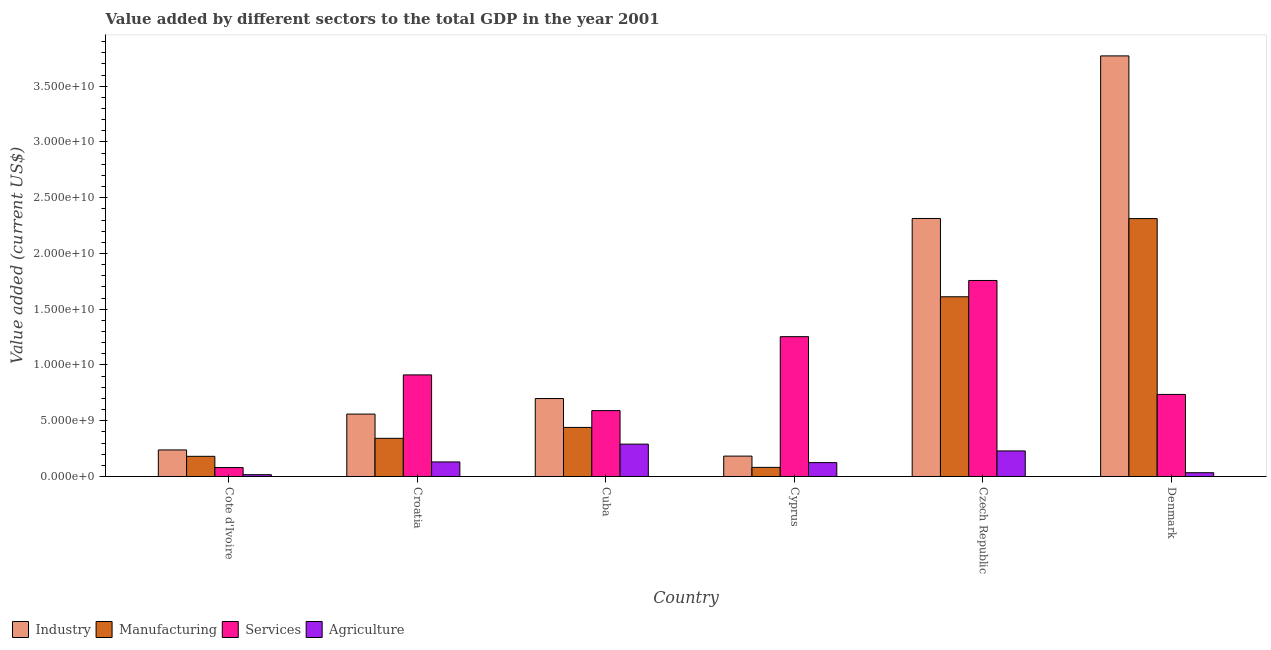Are the number of bars per tick equal to the number of legend labels?
Ensure brevity in your answer.  Yes. How many bars are there on the 6th tick from the left?
Give a very brief answer. 4. How many bars are there on the 3rd tick from the right?
Provide a succinct answer. 4. What is the label of the 5th group of bars from the left?
Your answer should be compact. Czech Republic. What is the value added by manufacturing sector in Cyprus?
Give a very brief answer. 8.16e+08. Across all countries, what is the maximum value added by manufacturing sector?
Give a very brief answer. 2.31e+1. Across all countries, what is the minimum value added by services sector?
Offer a terse response. 8.02e+08. In which country was the value added by industrial sector minimum?
Ensure brevity in your answer.  Cyprus. What is the total value added by services sector in the graph?
Your response must be concise. 5.33e+1. What is the difference between the value added by agricultural sector in Cote d'Ivoire and that in Cyprus?
Provide a succinct answer. -1.08e+09. What is the difference between the value added by manufacturing sector in Croatia and the value added by industrial sector in Cyprus?
Ensure brevity in your answer.  1.59e+09. What is the average value added by industrial sector per country?
Provide a short and direct response. 1.29e+1. What is the difference between the value added by services sector and value added by industrial sector in Cuba?
Offer a very short reply. -1.08e+09. In how many countries, is the value added by industrial sector greater than 5000000000 US$?
Your answer should be very brief. 4. What is the ratio of the value added by manufacturing sector in Cuba to that in Cyprus?
Give a very brief answer. 5.4. Is the difference between the value added by agricultural sector in Czech Republic and Denmark greater than the difference between the value added by industrial sector in Czech Republic and Denmark?
Offer a very short reply. Yes. What is the difference between the highest and the second highest value added by manufacturing sector?
Provide a short and direct response. 7.01e+09. What is the difference between the highest and the lowest value added by manufacturing sector?
Give a very brief answer. 2.23e+1. What does the 1st bar from the left in Croatia represents?
Ensure brevity in your answer.  Industry. What does the 2nd bar from the right in Croatia represents?
Offer a terse response. Services. How many bars are there?
Your response must be concise. 24. Are all the bars in the graph horizontal?
Your answer should be compact. No. What is the difference between two consecutive major ticks on the Y-axis?
Offer a very short reply. 5.00e+09. Does the graph contain grids?
Ensure brevity in your answer.  No. Where does the legend appear in the graph?
Your answer should be very brief. Bottom left. How many legend labels are there?
Provide a short and direct response. 4. What is the title of the graph?
Offer a terse response. Value added by different sectors to the total GDP in the year 2001. What is the label or title of the X-axis?
Your answer should be compact. Country. What is the label or title of the Y-axis?
Offer a terse response. Value added (current US$). What is the Value added (current US$) in Industry in Cote d'Ivoire?
Your answer should be compact. 2.38e+09. What is the Value added (current US$) of Manufacturing in Cote d'Ivoire?
Your answer should be compact. 1.81e+09. What is the Value added (current US$) of Services in Cote d'Ivoire?
Provide a succinct answer. 8.02e+08. What is the Value added (current US$) in Agriculture in Cote d'Ivoire?
Offer a very short reply. 1.62e+08. What is the Value added (current US$) of Industry in Croatia?
Your answer should be very brief. 5.60e+09. What is the Value added (current US$) of Manufacturing in Croatia?
Your answer should be very brief. 3.42e+09. What is the Value added (current US$) of Services in Croatia?
Your response must be concise. 9.11e+09. What is the Value added (current US$) of Agriculture in Croatia?
Your answer should be compact. 1.30e+09. What is the Value added (current US$) of Industry in Cuba?
Keep it short and to the point. 6.99e+09. What is the Value added (current US$) in Manufacturing in Cuba?
Keep it short and to the point. 4.40e+09. What is the Value added (current US$) of Services in Cuba?
Provide a succinct answer. 5.91e+09. What is the Value added (current US$) of Agriculture in Cuba?
Provide a succinct answer. 2.90e+09. What is the Value added (current US$) of Industry in Cyprus?
Your response must be concise. 1.83e+09. What is the Value added (current US$) of Manufacturing in Cyprus?
Provide a short and direct response. 8.16e+08. What is the Value added (current US$) of Services in Cyprus?
Your answer should be very brief. 1.25e+1. What is the Value added (current US$) in Agriculture in Cyprus?
Offer a very short reply. 1.24e+09. What is the Value added (current US$) of Industry in Czech Republic?
Your answer should be very brief. 2.31e+1. What is the Value added (current US$) of Manufacturing in Czech Republic?
Offer a terse response. 1.61e+1. What is the Value added (current US$) of Services in Czech Republic?
Your response must be concise. 1.76e+1. What is the Value added (current US$) of Agriculture in Czech Republic?
Provide a short and direct response. 2.29e+09. What is the Value added (current US$) in Industry in Denmark?
Ensure brevity in your answer.  3.77e+1. What is the Value added (current US$) of Manufacturing in Denmark?
Give a very brief answer. 2.31e+1. What is the Value added (current US$) of Services in Denmark?
Ensure brevity in your answer.  7.36e+09. What is the Value added (current US$) of Agriculture in Denmark?
Give a very brief answer. 3.39e+08. Across all countries, what is the maximum Value added (current US$) in Industry?
Ensure brevity in your answer.  3.77e+1. Across all countries, what is the maximum Value added (current US$) of Manufacturing?
Offer a very short reply. 2.31e+1. Across all countries, what is the maximum Value added (current US$) of Services?
Your response must be concise. 1.76e+1. Across all countries, what is the maximum Value added (current US$) in Agriculture?
Offer a very short reply. 2.90e+09. Across all countries, what is the minimum Value added (current US$) of Industry?
Offer a very short reply. 1.83e+09. Across all countries, what is the minimum Value added (current US$) in Manufacturing?
Offer a terse response. 8.16e+08. Across all countries, what is the minimum Value added (current US$) of Services?
Keep it short and to the point. 8.02e+08. Across all countries, what is the minimum Value added (current US$) of Agriculture?
Your response must be concise. 1.62e+08. What is the total Value added (current US$) of Industry in the graph?
Give a very brief answer. 7.77e+1. What is the total Value added (current US$) of Manufacturing in the graph?
Your response must be concise. 4.97e+1. What is the total Value added (current US$) in Services in the graph?
Give a very brief answer. 5.33e+1. What is the total Value added (current US$) of Agriculture in the graph?
Ensure brevity in your answer.  8.24e+09. What is the difference between the Value added (current US$) of Industry in Cote d'Ivoire and that in Croatia?
Keep it short and to the point. -3.21e+09. What is the difference between the Value added (current US$) in Manufacturing in Cote d'Ivoire and that in Croatia?
Give a very brief answer. -1.61e+09. What is the difference between the Value added (current US$) of Services in Cote d'Ivoire and that in Croatia?
Offer a terse response. -8.31e+09. What is the difference between the Value added (current US$) of Agriculture in Cote d'Ivoire and that in Croatia?
Your answer should be compact. -1.14e+09. What is the difference between the Value added (current US$) of Industry in Cote d'Ivoire and that in Cuba?
Offer a terse response. -4.61e+09. What is the difference between the Value added (current US$) in Manufacturing in Cote d'Ivoire and that in Cuba?
Give a very brief answer. -2.59e+09. What is the difference between the Value added (current US$) in Services in Cote d'Ivoire and that in Cuba?
Your response must be concise. -5.11e+09. What is the difference between the Value added (current US$) in Agriculture in Cote d'Ivoire and that in Cuba?
Your response must be concise. -2.74e+09. What is the difference between the Value added (current US$) of Industry in Cote d'Ivoire and that in Cyprus?
Your answer should be very brief. 5.53e+08. What is the difference between the Value added (current US$) in Manufacturing in Cote d'Ivoire and that in Cyprus?
Your answer should be compact. 9.93e+08. What is the difference between the Value added (current US$) in Services in Cote d'Ivoire and that in Cyprus?
Offer a very short reply. -1.17e+1. What is the difference between the Value added (current US$) in Agriculture in Cote d'Ivoire and that in Cyprus?
Offer a very short reply. -1.08e+09. What is the difference between the Value added (current US$) of Industry in Cote d'Ivoire and that in Czech Republic?
Make the answer very short. -2.08e+1. What is the difference between the Value added (current US$) in Manufacturing in Cote d'Ivoire and that in Czech Republic?
Ensure brevity in your answer.  -1.43e+1. What is the difference between the Value added (current US$) in Services in Cote d'Ivoire and that in Czech Republic?
Offer a terse response. -1.68e+1. What is the difference between the Value added (current US$) in Agriculture in Cote d'Ivoire and that in Czech Republic?
Your answer should be very brief. -2.13e+09. What is the difference between the Value added (current US$) of Industry in Cote d'Ivoire and that in Denmark?
Your answer should be very brief. -3.53e+1. What is the difference between the Value added (current US$) of Manufacturing in Cote d'Ivoire and that in Denmark?
Your response must be concise. -2.13e+1. What is the difference between the Value added (current US$) in Services in Cote d'Ivoire and that in Denmark?
Your answer should be very brief. -6.56e+09. What is the difference between the Value added (current US$) of Agriculture in Cote d'Ivoire and that in Denmark?
Offer a terse response. -1.77e+08. What is the difference between the Value added (current US$) in Industry in Croatia and that in Cuba?
Your answer should be compact. -1.39e+09. What is the difference between the Value added (current US$) of Manufacturing in Croatia and that in Cuba?
Provide a succinct answer. -9.79e+08. What is the difference between the Value added (current US$) in Services in Croatia and that in Cuba?
Provide a succinct answer. 3.20e+09. What is the difference between the Value added (current US$) in Agriculture in Croatia and that in Cuba?
Provide a short and direct response. -1.60e+09. What is the difference between the Value added (current US$) in Industry in Croatia and that in Cyprus?
Your response must be concise. 3.77e+09. What is the difference between the Value added (current US$) in Manufacturing in Croatia and that in Cyprus?
Your answer should be compact. 2.61e+09. What is the difference between the Value added (current US$) in Services in Croatia and that in Cyprus?
Give a very brief answer. -3.43e+09. What is the difference between the Value added (current US$) of Agriculture in Croatia and that in Cyprus?
Give a very brief answer. 6.06e+07. What is the difference between the Value added (current US$) of Industry in Croatia and that in Czech Republic?
Give a very brief answer. -1.75e+1. What is the difference between the Value added (current US$) in Manufacturing in Croatia and that in Czech Republic?
Offer a terse response. -1.27e+1. What is the difference between the Value added (current US$) of Services in Croatia and that in Czech Republic?
Ensure brevity in your answer.  -8.47e+09. What is the difference between the Value added (current US$) of Agriculture in Croatia and that in Czech Republic?
Your answer should be compact. -9.87e+08. What is the difference between the Value added (current US$) in Industry in Croatia and that in Denmark?
Your answer should be compact. -3.21e+1. What is the difference between the Value added (current US$) in Manufacturing in Croatia and that in Denmark?
Provide a succinct answer. -1.97e+1. What is the difference between the Value added (current US$) in Services in Croatia and that in Denmark?
Keep it short and to the point. 1.75e+09. What is the difference between the Value added (current US$) in Agriculture in Croatia and that in Denmark?
Your answer should be compact. 9.66e+08. What is the difference between the Value added (current US$) of Industry in Cuba and that in Cyprus?
Make the answer very short. 5.16e+09. What is the difference between the Value added (current US$) of Manufacturing in Cuba and that in Cyprus?
Provide a short and direct response. 3.59e+09. What is the difference between the Value added (current US$) in Services in Cuba and that in Cyprus?
Offer a very short reply. -6.63e+09. What is the difference between the Value added (current US$) in Agriculture in Cuba and that in Cyprus?
Your answer should be compact. 1.66e+09. What is the difference between the Value added (current US$) of Industry in Cuba and that in Czech Republic?
Make the answer very short. -1.62e+1. What is the difference between the Value added (current US$) in Manufacturing in Cuba and that in Czech Republic?
Your answer should be compact. -1.17e+1. What is the difference between the Value added (current US$) in Services in Cuba and that in Czech Republic?
Offer a very short reply. -1.17e+1. What is the difference between the Value added (current US$) of Agriculture in Cuba and that in Czech Republic?
Give a very brief answer. 6.10e+08. What is the difference between the Value added (current US$) in Industry in Cuba and that in Denmark?
Ensure brevity in your answer.  -3.07e+1. What is the difference between the Value added (current US$) in Manufacturing in Cuba and that in Denmark?
Keep it short and to the point. -1.87e+1. What is the difference between the Value added (current US$) of Services in Cuba and that in Denmark?
Your answer should be very brief. -1.45e+09. What is the difference between the Value added (current US$) in Agriculture in Cuba and that in Denmark?
Ensure brevity in your answer.  2.56e+09. What is the difference between the Value added (current US$) of Industry in Cyprus and that in Czech Republic?
Your answer should be very brief. -2.13e+1. What is the difference between the Value added (current US$) of Manufacturing in Cyprus and that in Czech Republic?
Offer a terse response. -1.53e+1. What is the difference between the Value added (current US$) of Services in Cyprus and that in Czech Republic?
Your answer should be compact. -5.04e+09. What is the difference between the Value added (current US$) of Agriculture in Cyprus and that in Czech Republic?
Offer a very short reply. -1.05e+09. What is the difference between the Value added (current US$) of Industry in Cyprus and that in Denmark?
Make the answer very short. -3.59e+1. What is the difference between the Value added (current US$) of Manufacturing in Cyprus and that in Denmark?
Your answer should be compact. -2.23e+1. What is the difference between the Value added (current US$) in Services in Cyprus and that in Denmark?
Keep it short and to the point. 5.18e+09. What is the difference between the Value added (current US$) in Agriculture in Cyprus and that in Denmark?
Offer a terse response. 9.05e+08. What is the difference between the Value added (current US$) of Industry in Czech Republic and that in Denmark?
Your answer should be very brief. -1.46e+1. What is the difference between the Value added (current US$) of Manufacturing in Czech Republic and that in Denmark?
Offer a terse response. -7.01e+09. What is the difference between the Value added (current US$) of Services in Czech Republic and that in Denmark?
Make the answer very short. 1.02e+1. What is the difference between the Value added (current US$) in Agriculture in Czech Republic and that in Denmark?
Keep it short and to the point. 1.95e+09. What is the difference between the Value added (current US$) in Industry in Cote d'Ivoire and the Value added (current US$) in Manufacturing in Croatia?
Make the answer very short. -1.04e+09. What is the difference between the Value added (current US$) of Industry in Cote d'Ivoire and the Value added (current US$) of Services in Croatia?
Provide a short and direct response. -6.73e+09. What is the difference between the Value added (current US$) in Industry in Cote d'Ivoire and the Value added (current US$) in Agriculture in Croatia?
Give a very brief answer. 1.08e+09. What is the difference between the Value added (current US$) of Manufacturing in Cote d'Ivoire and the Value added (current US$) of Services in Croatia?
Ensure brevity in your answer.  -7.30e+09. What is the difference between the Value added (current US$) of Manufacturing in Cote d'Ivoire and the Value added (current US$) of Agriculture in Croatia?
Keep it short and to the point. 5.04e+08. What is the difference between the Value added (current US$) in Services in Cote d'Ivoire and the Value added (current US$) in Agriculture in Croatia?
Make the answer very short. -5.02e+08. What is the difference between the Value added (current US$) in Industry in Cote d'Ivoire and the Value added (current US$) in Manufacturing in Cuba?
Make the answer very short. -2.02e+09. What is the difference between the Value added (current US$) of Industry in Cote d'Ivoire and the Value added (current US$) of Services in Cuba?
Keep it short and to the point. -3.53e+09. What is the difference between the Value added (current US$) of Industry in Cote d'Ivoire and the Value added (current US$) of Agriculture in Cuba?
Provide a succinct answer. -5.20e+08. What is the difference between the Value added (current US$) of Manufacturing in Cote d'Ivoire and the Value added (current US$) of Services in Cuba?
Offer a very short reply. -4.10e+09. What is the difference between the Value added (current US$) in Manufacturing in Cote d'Ivoire and the Value added (current US$) in Agriculture in Cuba?
Make the answer very short. -1.09e+09. What is the difference between the Value added (current US$) of Services in Cote d'Ivoire and the Value added (current US$) of Agriculture in Cuba?
Your answer should be very brief. -2.10e+09. What is the difference between the Value added (current US$) of Industry in Cote d'Ivoire and the Value added (current US$) of Manufacturing in Cyprus?
Keep it short and to the point. 1.57e+09. What is the difference between the Value added (current US$) in Industry in Cote d'Ivoire and the Value added (current US$) in Services in Cyprus?
Ensure brevity in your answer.  -1.02e+1. What is the difference between the Value added (current US$) in Industry in Cote d'Ivoire and the Value added (current US$) in Agriculture in Cyprus?
Provide a succinct answer. 1.14e+09. What is the difference between the Value added (current US$) in Manufacturing in Cote d'Ivoire and the Value added (current US$) in Services in Cyprus?
Provide a short and direct response. -1.07e+1. What is the difference between the Value added (current US$) of Manufacturing in Cote d'Ivoire and the Value added (current US$) of Agriculture in Cyprus?
Make the answer very short. 5.64e+08. What is the difference between the Value added (current US$) of Services in Cote d'Ivoire and the Value added (current US$) of Agriculture in Cyprus?
Your answer should be very brief. -4.42e+08. What is the difference between the Value added (current US$) in Industry in Cote d'Ivoire and the Value added (current US$) in Manufacturing in Czech Republic?
Your answer should be very brief. -1.37e+1. What is the difference between the Value added (current US$) of Industry in Cote d'Ivoire and the Value added (current US$) of Services in Czech Republic?
Ensure brevity in your answer.  -1.52e+1. What is the difference between the Value added (current US$) of Industry in Cote d'Ivoire and the Value added (current US$) of Agriculture in Czech Republic?
Ensure brevity in your answer.  8.92e+07. What is the difference between the Value added (current US$) in Manufacturing in Cote d'Ivoire and the Value added (current US$) in Services in Czech Republic?
Your response must be concise. -1.58e+1. What is the difference between the Value added (current US$) of Manufacturing in Cote d'Ivoire and the Value added (current US$) of Agriculture in Czech Republic?
Ensure brevity in your answer.  -4.84e+08. What is the difference between the Value added (current US$) in Services in Cote d'Ivoire and the Value added (current US$) in Agriculture in Czech Republic?
Offer a terse response. -1.49e+09. What is the difference between the Value added (current US$) in Industry in Cote d'Ivoire and the Value added (current US$) in Manufacturing in Denmark?
Offer a very short reply. -2.07e+1. What is the difference between the Value added (current US$) in Industry in Cote d'Ivoire and the Value added (current US$) in Services in Denmark?
Provide a succinct answer. -4.98e+09. What is the difference between the Value added (current US$) in Industry in Cote d'Ivoire and the Value added (current US$) in Agriculture in Denmark?
Offer a very short reply. 2.04e+09. What is the difference between the Value added (current US$) of Manufacturing in Cote d'Ivoire and the Value added (current US$) of Services in Denmark?
Provide a succinct answer. -5.55e+09. What is the difference between the Value added (current US$) of Manufacturing in Cote d'Ivoire and the Value added (current US$) of Agriculture in Denmark?
Your answer should be compact. 1.47e+09. What is the difference between the Value added (current US$) of Services in Cote d'Ivoire and the Value added (current US$) of Agriculture in Denmark?
Your answer should be compact. 4.63e+08. What is the difference between the Value added (current US$) in Industry in Croatia and the Value added (current US$) in Manufacturing in Cuba?
Your answer should be very brief. 1.19e+09. What is the difference between the Value added (current US$) in Industry in Croatia and the Value added (current US$) in Services in Cuba?
Your answer should be very brief. -3.13e+08. What is the difference between the Value added (current US$) of Industry in Croatia and the Value added (current US$) of Agriculture in Cuba?
Make the answer very short. 2.69e+09. What is the difference between the Value added (current US$) of Manufacturing in Croatia and the Value added (current US$) of Services in Cuba?
Provide a succinct answer. -2.49e+09. What is the difference between the Value added (current US$) of Manufacturing in Croatia and the Value added (current US$) of Agriculture in Cuba?
Your answer should be compact. 5.21e+08. What is the difference between the Value added (current US$) in Services in Croatia and the Value added (current US$) in Agriculture in Cuba?
Offer a terse response. 6.21e+09. What is the difference between the Value added (current US$) in Industry in Croatia and the Value added (current US$) in Manufacturing in Cyprus?
Offer a terse response. 4.78e+09. What is the difference between the Value added (current US$) in Industry in Croatia and the Value added (current US$) in Services in Cyprus?
Ensure brevity in your answer.  -6.94e+09. What is the difference between the Value added (current US$) in Industry in Croatia and the Value added (current US$) in Agriculture in Cyprus?
Offer a very short reply. 4.35e+09. What is the difference between the Value added (current US$) of Manufacturing in Croatia and the Value added (current US$) of Services in Cyprus?
Give a very brief answer. -9.12e+09. What is the difference between the Value added (current US$) of Manufacturing in Croatia and the Value added (current US$) of Agriculture in Cyprus?
Offer a very short reply. 2.18e+09. What is the difference between the Value added (current US$) of Services in Croatia and the Value added (current US$) of Agriculture in Cyprus?
Provide a succinct answer. 7.87e+09. What is the difference between the Value added (current US$) in Industry in Croatia and the Value added (current US$) in Manufacturing in Czech Republic?
Offer a terse response. -1.05e+1. What is the difference between the Value added (current US$) of Industry in Croatia and the Value added (current US$) of Services in Czech Republic?
Keep it short and to the point. -1.20e+1. What is the difference between the Value added (current US$) of Industry in Croatia and the Value added (current US$) of Agriculture in Czech Republic?
Offer a very short reply. 3.30e+09. What is the difference between the Value added (current US$) in Manufacturing in Croatia and the Value added (current US$) in Services in Czech Republic?
Ensure brevity in your answer.  -1.42e+1. What is the difference between the Value added (current US$) in Manufacturing in Croatia and the Value added (current US$) in Agriculture in Czech Republic?
Offer a very short reply. 1.13e+09. What is the difference between the Value added (current US$) in Services in Croatia and the Value added (current US$) in Agriculture in Czech Republic?
Provide a short and direct response. 6.82e+09. What is the difference between the Value added (current US$) of Industry in Croatia and the Value added (current US$) of Manufacturing in Denmark?
Offer a terse response. -1.75e+1. What is the difference between the Value added (current US$) in Industry in Croatia and the Value added (current US$) in Services in Denmark?
Your answer should be very brief. -1.76e+09. What is the difference between the Value added (current US$) in Industry in Croatia and the Value added (current US$) in Agriculture in Denmark?
Your response must be concise. 5.26e+09. What is the difference between the Value added (current US$) in Manufacturing in Croatia and the Value added (current US$) in Services in Denmark?
Your answer should be very brief. -3.94e+09. What is the difference between the Value added (current US$) of Manufacturing in Croatia and the Value added (current US$) of Agriculture in Denmark?
Your response must be concise. 3.08e+09. What is the difference between the Value added (current US$) of Services in Croatia and the Value added (current US$) of Agriculture in Denmark?
Your response must be concise. 8.77e+09. What is the difference between the Value added (current US$) in Industry in Cuba and the Value added (current US$) in Manufacturing in Cyprus?
Your response must be concise. 6.17e+09. What is the difference between the Value added (current US$) of Industry in Cuba and the Value added (current US$) of Services in Cyprus?
Offer a very short reply. -5.55e+09. What is the difference between the Value added (current US$) of Industry in Cuba and the Value added (current US$) of Agriculture in Cyprus?
Ensure brevity in your answer.  5.75e+09. What is the difference between the Value added (current US$) of Manufacturing in Cuba and the Value added (current US$) of Services in Cyprus?
Keep it short and to the point. -8.14e+09. What is the difference between the Value added (current US$) in Manufacturing in Cuba and the Value added (current US$) in Agriculture in Cyprus?
Your answer should be very brief. 3.16e+09. What is the difference between the Value added (current US$) in Services in Cuba and the Value added (current US$) in Agriculture in Cyprus?
Ensure brevity in your answer.  4.67e+09. What is the difference between the Value added (current US$) of Industry in Cuba and the Value added (current US$) of Manufacturing in Czech Republic?
Offer a very short reply. -9.13e+09. What is the difference between the Value added (current US$) in Industry in Cuba and the Value added (current US$) in Services in Czech Republic?
Ensure brevity in your answer.  -1.06e+1. What is the difference between the Value added (current US$) of Industry in Cuba and the Value added (current US$) of Agriculture in Czech Republic?
Offer a very short reply. 4.70e+09. What is the difference between the Value added (current US$) of Manufacturing in Cuba and the Value added (current US$) of Services in Czech Republic?
Your response must be concise. -1.32e+1. What is the difference between the Value added (current US$) in Manufacturing in Cuba and the Value added (current US$) in Agriculture in Czech Republic?
Keep it short and to the point. 2.11e+09. What is the difference between the Value added (current US$) of Services in Cuba and the Value added (current US$) of Agriculture in Czech Republic?
Keep it short and to the point. 3.62e+09. What is the difference between the Value added (current US$) of Industry in Cuba and the Value added (current US$) of Manufacturing in Denmark?
Offer a terse response. -1.61e+1. What is the difference between the Value added (current US$) of Industry in Cuba and the Value added (current US$) of Services in Denmark?
Keep it short and to the point. -3.69e+08. What is the difference between the Value added (current US$) of Industry in Cuba and the Value added (current US$) of Agriculture in Denmark?
Provide a succinct answer. 6.65e+09. What is the difference between the Value added (current US$) in Manufacturing in Cuba and the Value added (current US$) in Services in Denmark?
Your answer should be compact. -2.96e+09. What is the difference between the Value added (current US$) of Manufacturing in Cuba and the Value added (current US$) of Agriculture in Denmark?
Make the answer very short. 4.06e+09. What is the difference between the Value added (current US$) in Services in Cuba and the Value added (current US$) in Agriculture in Denmark?
Provide a short and direct response. 5.57e+09. What is the difference between the Value added (current US$) of Industry in Cyprus and the Value added (current US$) of Manufacturing in Czech Republic?
Offer a very short reply. -1.43e+1. What is the difference between the Value added (current US$) in Industry in Cyprus and the Value added (current US$) in Services in Czech Republic?
Your answer should be compact. -1.58e+1. What is the difference between the Value added (current US$) in Industry in Cyprus and the Value added (current US$) in Agriculture in Czech Republic?
Ensure brevity in your answer.  -4.64e+08. What is the difference between the Value added (current US$) of Manufacturing in Cyprus and the Value added (current US$) of Services in Czech Republic?
Provide a succinct answer. -1.68e+1. What is the difference between the Value added (current US$) in Manufacturing in Cyprus and the Value added (current US$) in Agriculture in Czech Republic?
Your answer should be compact. -1.48e+09. What is the difference between the Value added (current US$) in Services in Cyprus and the Value added (current US$) in Agriculture in Czech Republic?
Your answer should be very brief. 1.02e+1. What is the difference between the Value added (current US$) in Industry in Cyprus and the Value added (current US$) in Manufacturing in Denmark?
Make the answer very short. -2.13e+1. What is the difference between the Value added (current US$) of Industry in Cyprus and the Value added (current US$) of Services in Denmark?
Provide a succinct answer. -5.53e+09. What is the difference between the Value added (current US$) of Industry in Cyprus and the Value added (current US$) of Agriculture in Denmark?
Make the answer very short. 1.49e+09. What is the difference between the Value added (current US$) of Manufacturing in Cyprus and the Value added (current US$) of Services in Denmark?
Keep it short and to the point. -6.54e+09. What is the difference between the Value added (current US$) of Manufacturing in Cyprus and the Value added (current US$) of Agriculture in Denmark?
Your answer should be compact. 4.77e+08. What is the difference between the Value added (current US$) in Services in Cyprus and the Value added (current US$) in Agriculture in Denmark?
Your answer should be compact. 1.22e+1. What is the difference between the Value added (current US$) of Industry in Czech Republic and the Value added (current US$) of Manufacturing in Denmark?
Keep it short and to the point. 1.02e+07. What is the difference between the Value added (current US$) in Industry in Czech Republic and the Value added (current US$) in Services in Denmark?
Ensure brevity in your answer.  1.58e+1. What is the difference between the Value added (current US$) of Industry in Czech Republic and the Value added (current US$) of Agriculture in Denmark?
Your answer should be very brief. 2.28e+1. What is the difference between the Value added (current US$) of Manufacturing in Czech Republic and the Value added (current US$) of Services in Denmark?
Keep it short and to the point. 8.76e+09. What is the difference between the Value added (current US$) of Manufacturing in Czech Republic and the Value added (current US$) of Agriculture in Denmark?
Make the answer very short. 1.58e+1. What is the difference between the Value added (current US$) of Services in Czech Republic and the Value added (current US$) of Agriculture in Denmark?
Provide a short and direct response. 1.72e+1. What is the average Value added (current US$) in Industry per country?
Provide a short and direct response. 1.29e+1. What is the average Value added (current US$) of Manufacturing per country?
Provide a succinct answer. 8.28e+09. What is the average Value added (current US$) in Services per country?
Your answer should be compact. 8.88e+09. What is the average Value added (current US$) of Agriculture per country?
Offer a very short reply. 1.37e+09. What is the difference between the Value added (current US$) of Industry and Value added (current US$) of Manufacturing in Cote d'Ivoire?
Offer a terse response. 5.73e+08. What is the difference between the Value added (current US$) in Industry and Value added (current US$) in Services in Cote d'Ivoire?
Provide a short and direct response. 1.58e+09. What is the difference between the Value added (current US$) of Industry and Value added (current US$) of Agriculture in Cote d'Ivoire?
Your response must be concise. 2.22e+09. What is the difference between the Value added (current US$) of Manufacturing and Value added (current US$) of Services in Cote d'Ivoire?
Provide a short and direct response. 1.01e+09. What is the difference between the Value added (current US$) in Manufacturing and Value added (current US$) in Agriculture in Cote d'Ivoire?
Keep it short and to the point. 1.65e+09. What is the difference between the Value added (current US$) of Services and Value added (current US$) of Agriculture in Cote d'Ivoire?
Offer a very short reply. 6.40e+08. What is the difference between the Value added (current US$) in Industry and Value added (current US$) in Manufacturing in Croatia?
Ensure brevity in your answer.  2.17e+09. What is the difference between the Value added (current US$) of Industry and Value added (current US$) of Services in Croatia?
Provide a succinct answer. -3.51e+09. What is the difference between the Value added (current US$) of Industry and Value added (current US$) of Agriculture in Croatia?
Provide a succinct answer. 4.29e+09. What is the difference between the Value added (current US$) in Manufacturing and Value added (current US$) in Services in Croatia?
Give a very brief answer. -5.69e+09. What is the difference between the Value added (current US$) of Manufacturing and Value added (current US$) of Agriculture in Croatia?
Give a very brief answer. 2.12e+09. What is the difference between the Value added (current US$) of Services and Value added (current US$) of Agriculture in Croatia?
Your response must be concise. 7.81e+09. What is the difference between the Value added (current US$) in Industry and Value added (current US$) in Manufacturing in Cuba?
Provide a short and direct response. 2.59e+09. What is the difference between the Value added (current US$) in Industry and Value added (current US$) in Services in Cuba?
Provide a succinct answer. 1.08e+09. What is the difference between the Value added (current US$) of Industry and Value added (current US$) of Agriculture in Cuba?
Provide a succinct answer. 4.09e+09. What is the difference between the Value added (current US$) of Manufacturing and Value added (current US$) of Services in Cuba?
Your answer should be very brief. -1.51e+09. What is the difference between the Value added (current US$) in Manufacturing and Value added (current US$) in Agriculture in Cuba?
Offer a terse response. 1.50e+09. What is the difference between the Value added (current US$) in Services and Value added (current US$) in Agriculture in Cuba?
Make the answer very short. 3.01e+09. What is the difference between the Value added (current US$) in Industry and Value added (current US$) in Manufacturing in Cyprus?
Provide a succinct answer. 1.01e+09. What is the difference between the Value added (current US$) of Industry and Value added (current US$) of Services in Cyprus?
Your response must be concise. -1.07e+1. What is the difference between the Value added (current US$) of Industry and Value added (current US$) of Agriculture in Cyprus?
Keep it short and to the point. 5.84e+08. What is the difference between the Value added (current US$) of Manufacturing and Value added (current US$) of Services in Cyprus?
Ensure brevity in your answer.  -1.17e+1. What is the difference between the Value added (current US$) in Manufacturing and Value added (current US$) in Agriculture in Cyprus?
Offer a very short reply. -4.28e+08. What is the difference between the Value added (current US$) of Services and Value added (current US$) of Agriculture in Cyprus?
Give a very brief answer. 1.13e+1. What is the difference between the Value added (current US$) of Industry and Value added (current US$) of Manufacturing in Czech Republic?
Offer a very short reply. 7.02e+09. What is the difference between the Value added (current US$) in Industry and Value added (current US$) in Services in Czech Republic?
Ensure brevity in your answer.  5.56e+09. What is the difference between the Value added (current US$) of Industry and Value added (current US$) of Agriculture in Czech Republic?
Keep it short and to the point. 2.08e+1. What is the difference between the Value added (current US$) in Manufacturing and Value added (current US$) in Services in Czech Republic?
Give a very brief answer. -1.46e+09. What is the difference between the Value added (current US$) of Manufacturing and Value added (current US$) of Agriculture in Czech Republic?
Offer a terse response. 1.38e+1. What is the difference between the Value added (current US$) in Services and Value added (current US$) in Agriculture in Czech Republic?
Your response must be concise. 1.53e+1. What is the difference between the Value added (current US$) of Industry and Value added (current US$) of Manufacturing in Denmark?
Keep it short and to the point. 1.46e+1. What is the difference between the Value added (current US$) of Industry and Value added (current US$) of Services in Denmark?
Your answer should be very brief. 3.04e+1. What is the difference between the Value added (current US$) of Industry and Value added (current US$) of Agriculture in Denmark?
Keep it short and to the point. 3.74e+1. What is the difference between the Value added (current US$) of Manufacturing and Value added (current US$) of Services in Denmark?
Give a very brief answer. 1.58e+1. What is the difference between the Value added (current US$) of Manufacturing and Value added (current US$) of Agriculture in Denmark?
Your response must be concise. 2.28e+1. What is the difference between the Value added (current US$) of Services and Value added (current US$) of Agriculture in Denmark?
Offer a very short reply. 7.02e+09. What is the ratio of the Value added (current US$) in Industry in Cote d'Ivoire to that in Croatia?
Your answer should be very brief. 0.43. What is the ratio of the Value added (current US$) in Manufacturing in Cote d'Ivoire to that in Croatia?
Ensure brevity in your answer.  0.53. What is the ratio of the Value added (current US$) of Services in Cote d'Ivoire to that in Croatia?
Provide a short and direct response. 0.09. What is the ratio of the Value added (current US$) of Agriculture in Cote d'Ivoire to that in Croatia?
Provide a short and direct response. 0.12. What is the ratio of the Value added (current US$) of Industry in Cote d'Ivoire to that in Cuba?
Provide a succinct answer. 0.34. What is the ratio of the Value added (current US$) in Manufacturing in Cote d'Ivoire to that in Cuba?
Make the answer very short. 0.41. What is the ratio of the Value added (current US$) of Services in Cote d'Ivoire to that in Cuba?
Your answer should be compact. 0.14. What is the ratio of the Value added (current US$) in Agriculture in Cote d'Ivoire to that in Cuba?
Offer a terse response. 0.06. What is the ratio of the Value added (current US$) in Industry in Cote d'Ivoire to that in Cyprus?
Provide a succinct answer. 1.3. What is the ratio of the Value added (current US$) in Manufacturing in Cote d'Ivoire to that in Cyprus?
Your answer should be very brief. 2.22. What is the ratio of the Value added (current US$) in Services in Cote d'Ivoire to that in Cyprus?
Your answer should be compact. 0.06. What is the ratio of the Value added (current US$) of Agriculture in Cote d'Ivoire to that in Cyprus?
Offer a very short reply. 0.13. What is the ratio of the Value added (current US$) in Industry in Cote d'Ivoire to that in Czech Republic?
Your answer should be compact. 0.1. What is the ratio of the Value added (current US$) of Manufacturing in Cote d'Ivoire to that in Czech Republic?
Offer a very short reply. 0.11. What is the ratio of the Value added (current US$) in Services in Cote d'Ivoire to that in Czech Republic?
Give a very brief answer. 0.05. What is the ratio of the Value added (current US$) in Agriculture in Cote d'Ivoire to that in Czech Republic?
Your response must be concise. 0.07. What is the ratio of the Value added (current US$) in Industry in Cote d'Ivoire to that in Denmark?
Provide a short and direct response. 0.06. What is the ratio of the Value added (current US$) of Manufacturing in Cote d'Ivoire to that in Denmark?
Offer a terse response. 0.08. What is the ratio of the Value added (current US$) in Services in Cote d'Ivoire to that in Denmark?
Offer a terse response. 0.11. What is the ratio of the Value added (current US$) of Agriculture in Cote d'Ivoire to that in Denmark?
Your answer should be very brief. 0.48. What is the ratio of the Value added (current US$) of Industry in Croatia to that in Cuba?
Provide a succinct answer. 0.8. What is the ratio of the Value added (current US$) in Manufacturing in Croatia to that in Cuba?
Offer a very short reply. 0.78. What is the ratio of the Value added (current US$) in Services in Croatia to that in Cuba?
Offer a terse response. 1.54. What is the ratio of the Value added (current US$) in Agriculture in Croatia to that in Cuba?
Provide a succinct answer. 0.45. What is the ratio of the Value added (current US$) in Industry in Croatia to that in Cyprus?
Make the answer very short. 3.06. What is the ratio of the Value added (current US$) of Manufacturing in Croatia to that in Cyprus?
Provide a succinct answer. 4.2. What is the ratio of the Value added (current US$) in Services in Croatia to that in Cyprus?
Keep it short and to the point. 0.73. What is the ratio of the Value added (current US$) in Agriculture in Croatia to that in Cyprus?
Give a very brief answer. 1.05. What is the ratio of the Value added (current US$) of Industry in Croatia to that in Czech Republic?
Your response must be concise. 0.24. What is the ratio of the Value added (current US$) in Manufacturing in Croatia to that in Czech Republic?
Keep it short and to the point. 0.21. What is the ratio of the Value added (current US$) in Services in Croatia to that in Czech Republic?
Give a very brief answer. 0.52. What is the ratio of the Value added (current US$) in Agriculture in Croatia to that in Czech Republic?
Give a very brief answer. 0.57. What is the ratio of the Value added (current US$) in Industry in Croatia to that in Denmark?
Provide a succinct answer. 0.15. What is the ratio of the Value added (current US$) of Manufacturing in Croatia to that in Denmark?
Provide a succinct answer. 0.15. What is the ratio of the Value added (current US$) of Services in Croatia to that in Denmark?
Keep it short and to the point. 1.24. What is the ratio of the Value added (current US$) in Agriculture in Croatia to that in Denmark?
Keep it short and to the point. 3.85. What is the ratio of the Value added (current US$) of Industry in Cuba to that in Cyprus?
Provide a succinct answer. 3.82. What is the ratio of the Value added (current US$) in Manufacturing in Cuba to that in Cyprus?
Offer a very short reply. 5.4. What is the ratio of the Value added (current US$) in Services in Cuba to that in Cyprus?
Offer a terse response. 0.47. What is the ratio of the Value added (current US$) of Agriculture in Cuba to that in Cyprus?
Ensure brevity in your answer.  2.33. What is the ratio of the Value added (current US$) in Industry in Cuba to that in Czech Republic?
Provide a succinct answer. 0.3. What is the ratio of the Value added (current US$) of Manufacturing in Cuba to that in Czech Republic?
Keep it short and to the point. 0.27. What is the ratio of the Value added (current US$) in Services in Cuba to that in Czech Republic?
Provide a succinct answer. 0.34. What is the ratio of the Value added (current US$) in Agriculture in Cuba to that in Czech Republic?
Offer a very short reply. 1.27. What is the ratio of the Value added (current US$) of Industry in Cuba to that in Denmark?
Offer a terse response. 0.19. What is the ratio of the Value added (current US$) of Manufacturing in Cuba to that in Denmark?
Offer a very short reply. 0.19. What is the ratio of the Value added (current US$) in Services in Cuba to that in Denmark?
Provide a short and direct response. 0.8. What is the ratio of the Value added (current US$) of Agriculture in Cuba to that in Denmark?
Make the answer very short. 8.56. What is the ratio of the Value added (current US$) of Industry in Cyprus to that in Czech Republic?
Ensure brevity in your answer.  0.08. What is the ratio of the Value added (current US$) in Manufacturing in Cyprus to that in Czech Republic?
Make the answer very short. 0.05. What is the ratio of the Value added (current US$) of Services in Cyprus to that in Czech Republic?
Make the answer very short. 0.71. What is the ratio of the Value added (current US$) of Agriculture in Cyprus to that in Czech Republic?
Give a very brief answer. 0.54. What is the ratio of the Value added (current US$) of Industry in Cyprus to that in Denmark?
Your answer should be compact. 0.05. What is the ratio of the Value added (current US$) of Manufacturing in Cyprus to that in Denmark?
Give a very brief answer. 0.04. What is the ratio of the Value added (current US$) of Services in Cyprus to that in Denmark?
Give a very brief answer. 1.7. What is the ratio of the Value added (current US$) in Agriculture in Cyprus to that in Denmark?
Provide a short and direct response. 3.67. What is the ratio of the Value added (current US$) in Industry in Czech Republic to that in Denmark?
Keep it short and to the point. 0.61. What is the ratio of the Value added (current US$) in Manufacturing in Czech Republic to that in Denmark?
Provide a succinct answer. 0.7. What is the ratio of the Value added (current US$) in Services in Czech Republic to that in Denmark?
Keep it short and to the point. 2.39. What is the ratio of the Value added (current US$) in Agriculture in Czech Republic to that in Denmark?
Provide a short and direct response. 6.76. What is the difference between the highest and the second highest Value added (current US$) of Industry?
Your answer should be very brief. 1.46e+1. What is the difference between the highest and the second highest Value added (current US$) of Manufacturing?
Offer a terse response. 7.01e+09. What is the difference between the highest and the second highest Value added (current US$) of Services?
Make the answer very short. 5.04e+09. What is the difference between the highest and the second highest Value added (current US$) in Agriculture?
Your response must be concise. 6.10e+08. What is the difference between the highest and the lowest Value added (current US$) of Industry?
Make the answer very short. 3.59e+1. What is the difference between the highest and the lowest Value added (current US$) in Manufacturing?
Give a very brief answer. 2.23e+1. What is the difference between the highest and the lowest Value added (current US$) in Services?
Keep it short and to the point. 1.68e+1. What is the difference between the highest and the lowest Value added (current US$) of Agriculture?
Provide a short and direct response. 2.74e+09. 